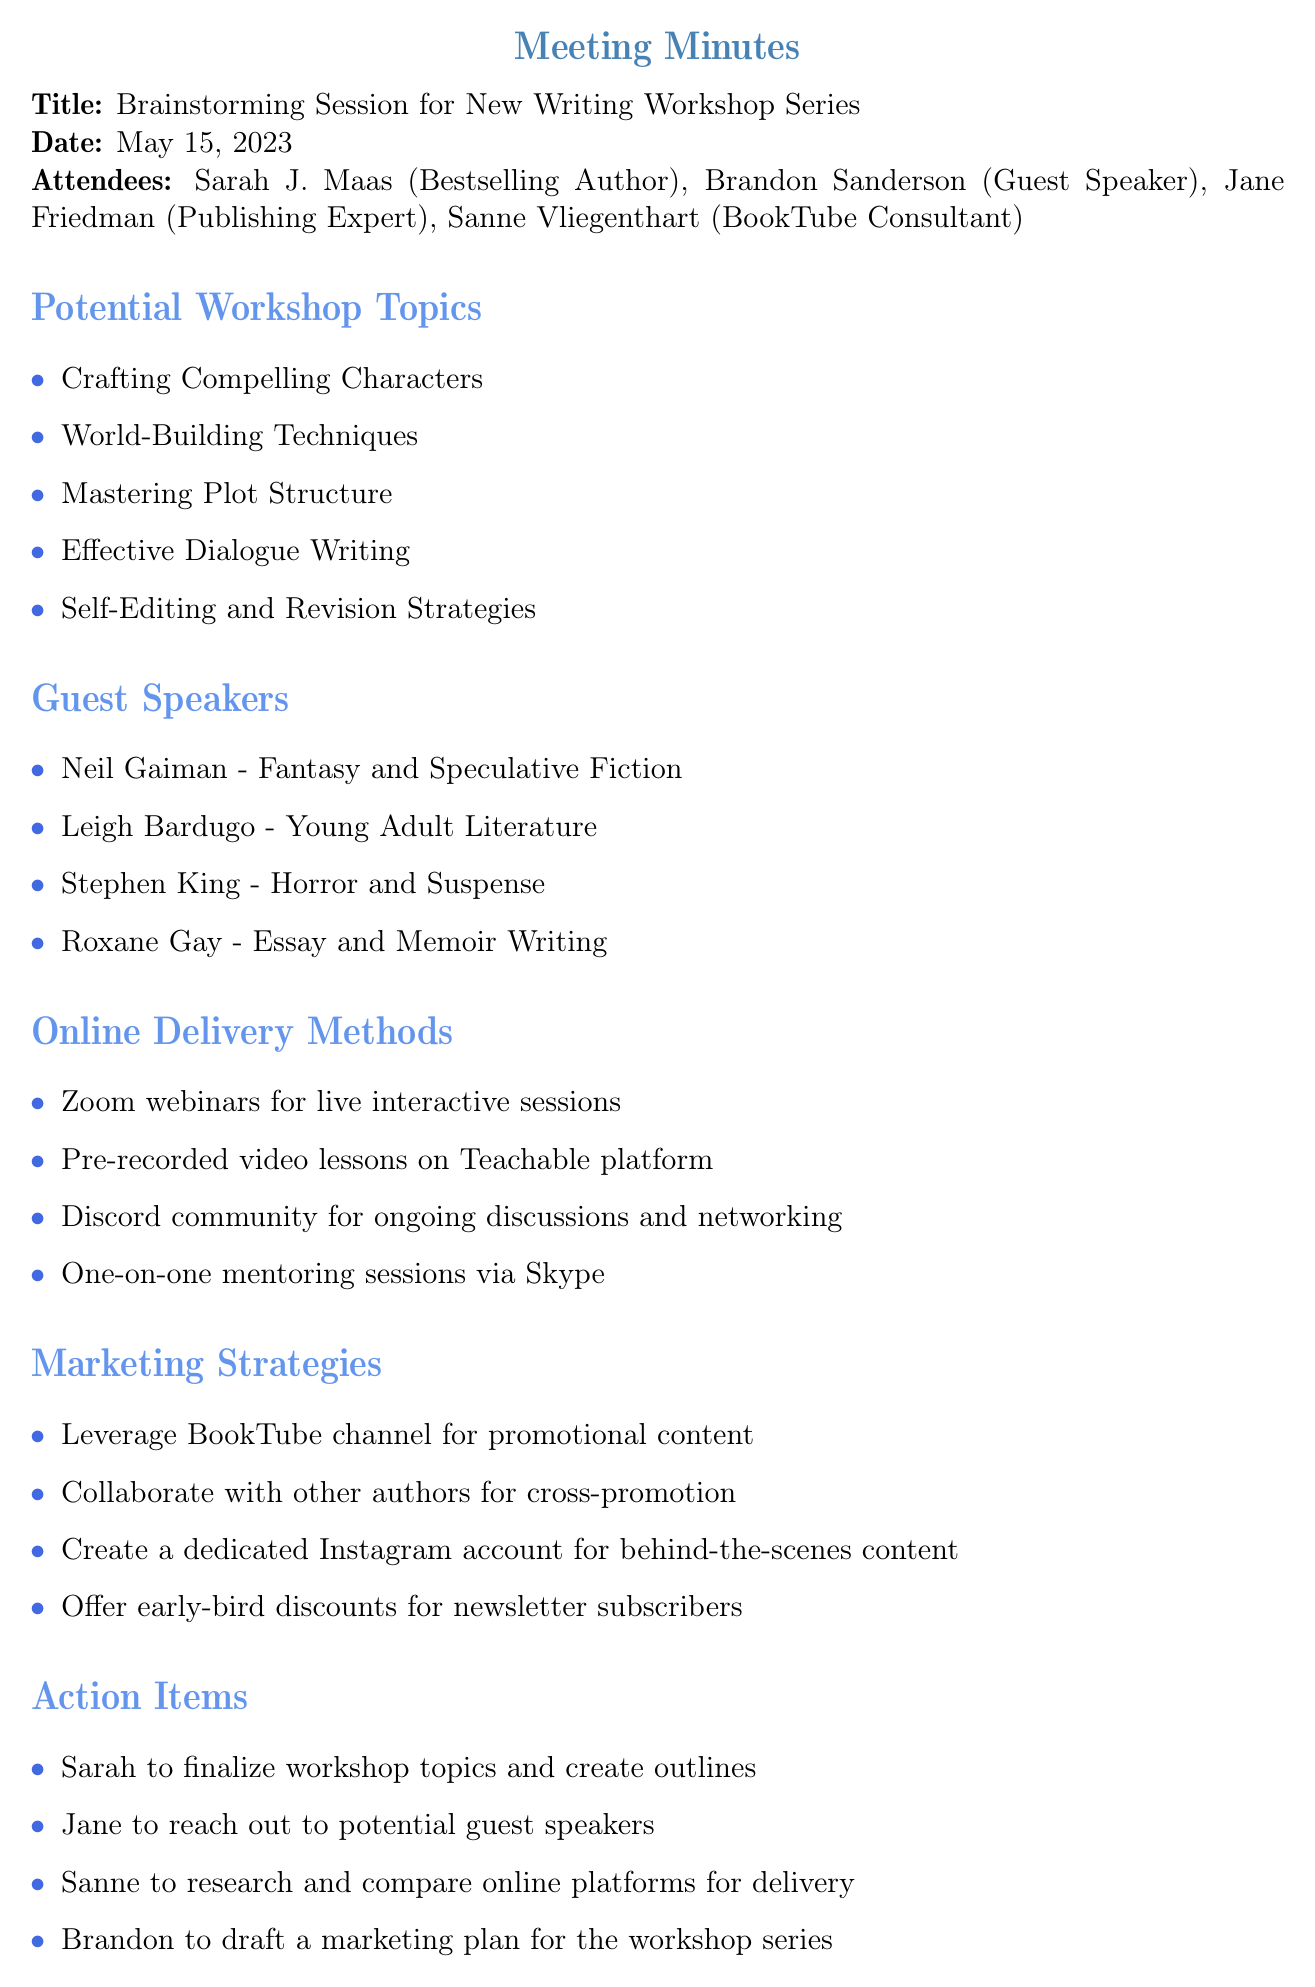What is the date of the meeting? The meeting was held on May 15, 2023.
Answer: May 15, 2023 Who are the guest speakers mentioned? The document lists Neil Gaiman, Leigh Bardugo, Stephen King, and Roxane Gay as guest speakers.
Answer: Neil Gaiman, Leigh Bardugo, Stephen King, Roxane Gay How many potential workshop topics are listed? The document provides five potential workshop topics.
Answer: Five What online delivery method allows for live interactive sessions? Zoom webinars are mentioned as the method for live interactive sessions.
Answer: Zoom webinars Which attendee is responsible for finalizing workshop topics? The action item states that Sarah will finalize the workshop topics.
Answer: Sarah What is one marketing strategy suggested in the meeting? One suggested marketing strategy is to leverage the BookTube channel for promotional content.
Answer: Leverage BookTube channel Which department was Sanne Vliegenthart associated with? The document indicates that Sanne is the BookTube Consultant.
Answer: BookTube Consultant What are the main topics discussed in the agenda? The agenda covers potential workshop topics, guest speakers, online delivery methods, marketing strategies, and action items.
Answer: Five main topics 